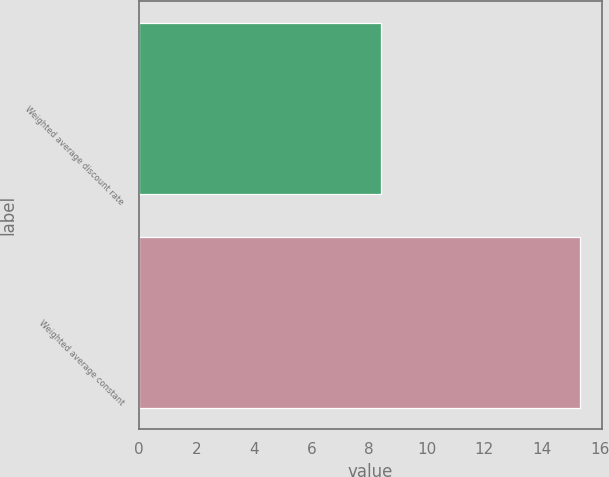<chart> <loc_0><loc_0><loc_500><loc_500><bar_chart><fcel>Weighted average discount rate<fcel>Weighted average constant<nl><fcel>8.4<fcel>15.3<nl></chart> 